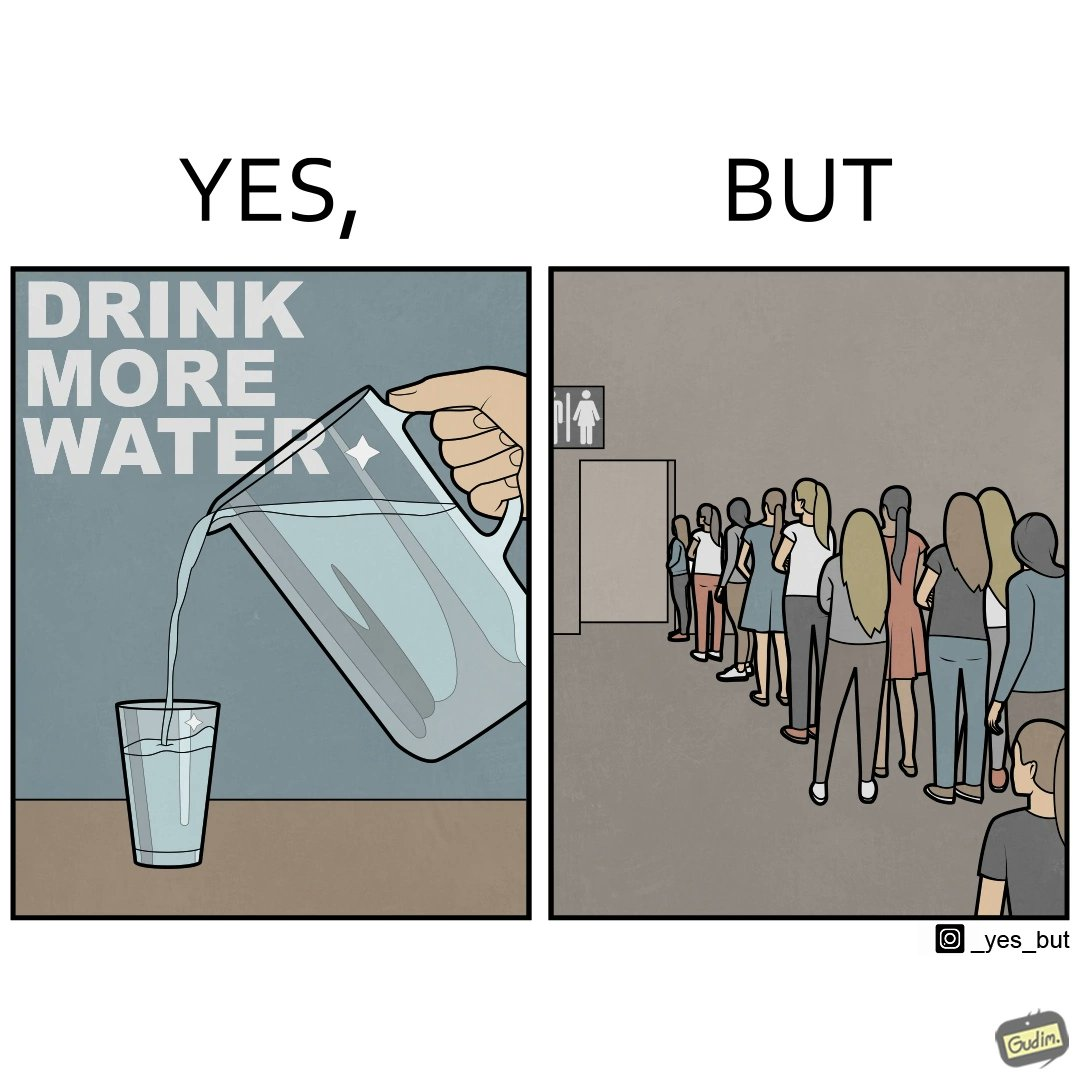What is shown in this image? The image is ironical, as the message "Drink more water" is meant to improve health, but in turn, it would lead to longer queues in front of public toilets, leading to people holding urine for longer periods, in turn leading to deterioration in health. 